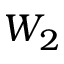<formula> <loc_0><loc_0><loc_500><loc_500>W _ { 2 }</formula> 